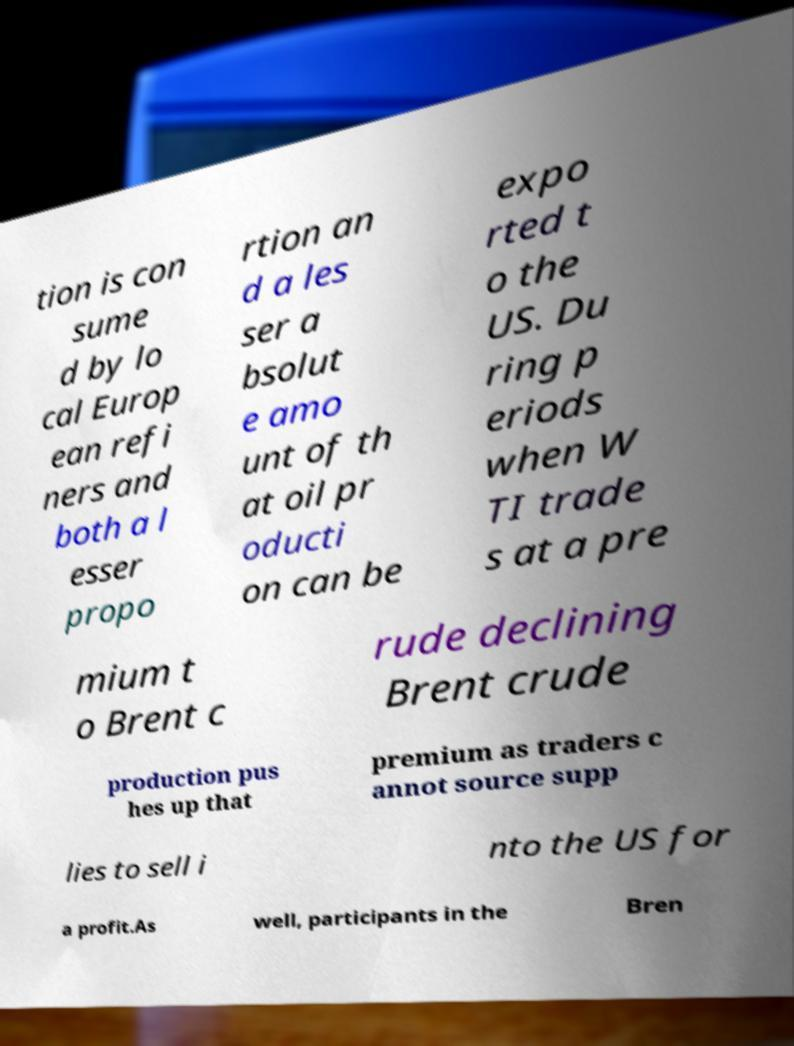Could you assist in decoding the text presented in this image and type it out clearly? tion is con sume d by lo cal Europ ean refi ners and both a l esser propo rtion an d a les ser a bsolut e amo unt of th at oil pr oducti on can be expo rted t o the US. Du ring p eriods when W TI trade s at a pre mium t o Brent c rude declining Brent crude production pus hes up that premium as traders c annot source supp lies to sell i nto the US for a profit.As well, participants in the Bren 